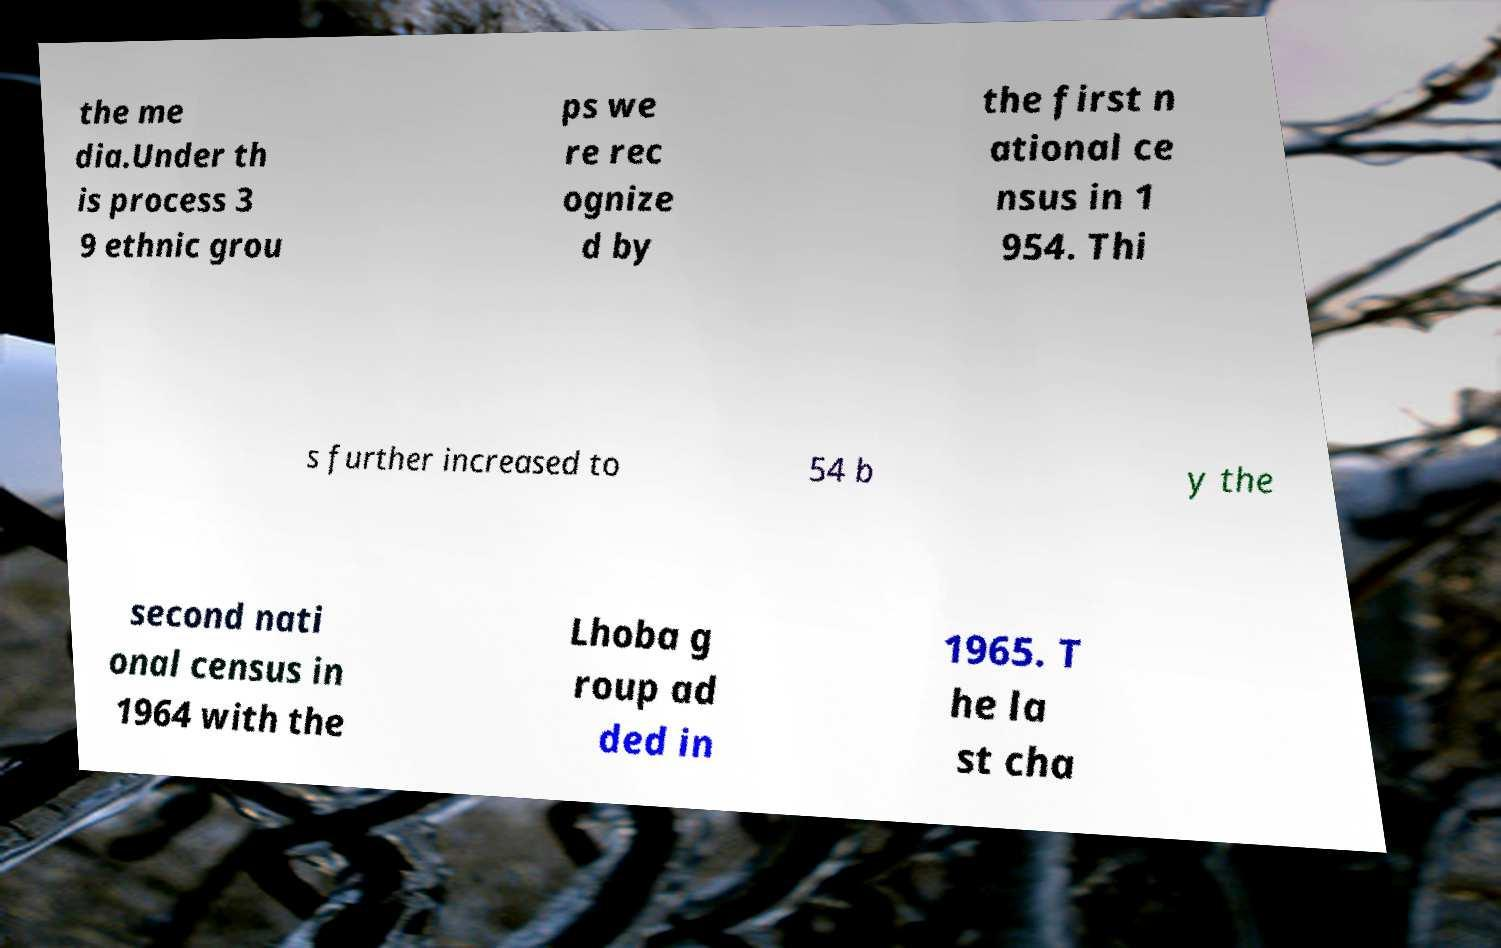Can you accurately transcribe the text from the provided image for me? the me dia.Under th is process 3 9 ethnic grou ps we re rec ognize d by the first n ational ce nsus in 1 954. Thi s further increased to 54 b y the second nati onal census in 1964 with the Lhoba g roup ad ded in 1965. T he la st cha 